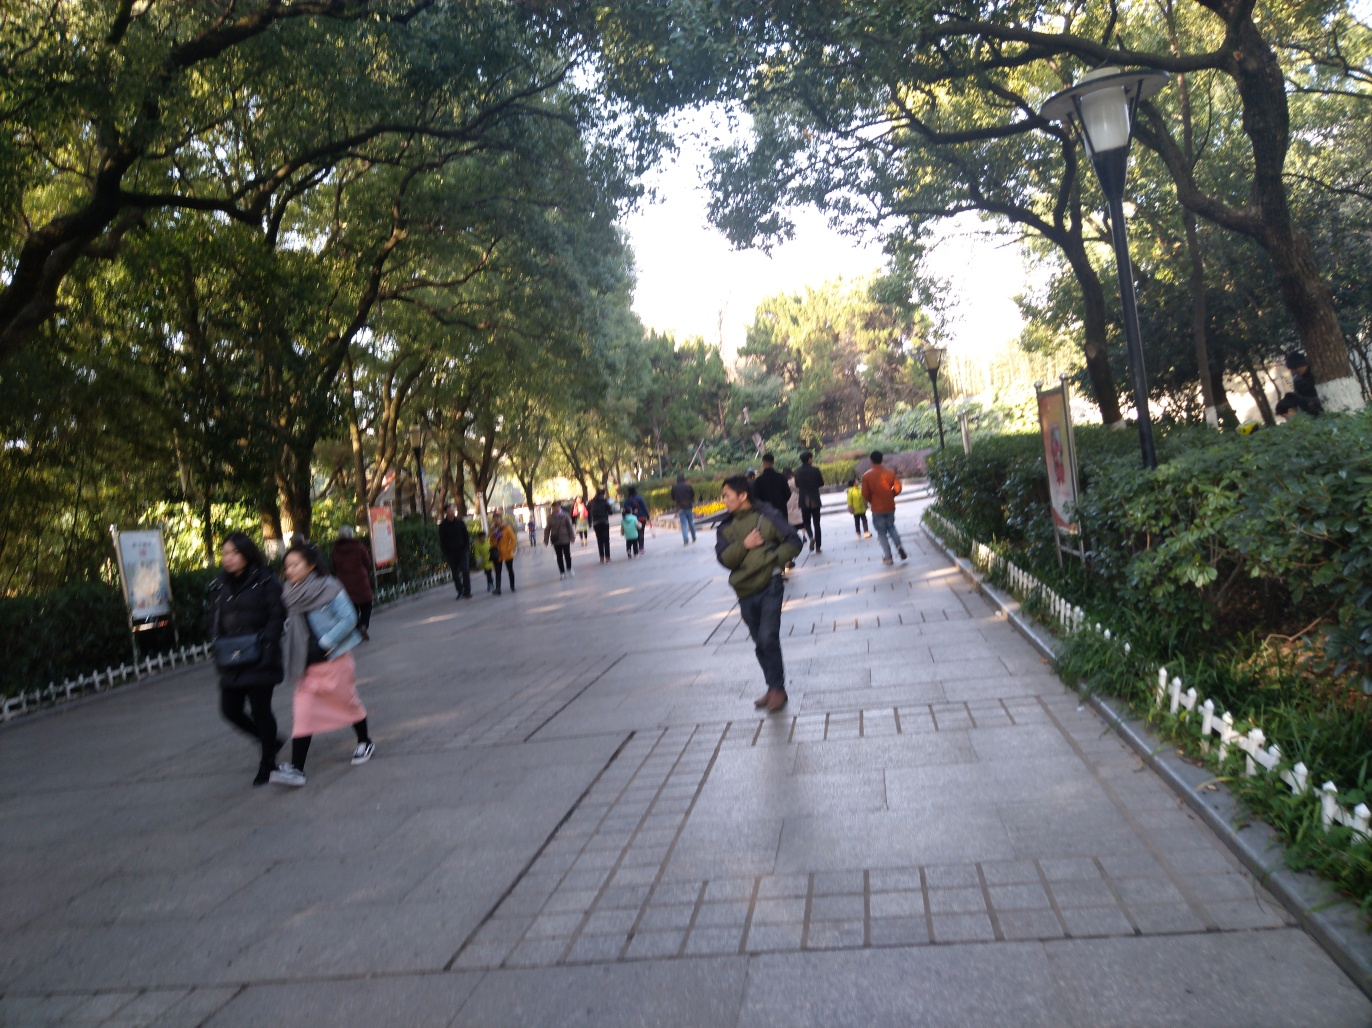Is the composition of this image good?
A. yes
B. perfect
C. excellent
D. no
Answer with the option's letter from the given choices directly. The composition of the image has some flaws. The photo appears to be taken with a slight tilt, affecting the balance and symmetry expected in a visually pleasing shot. Additionally, the image seems to be in motion blur which suggests that the camera wasn't steady during the shot. The subjects are also not in clear focus, and the lighting seems uncontrolled. While the scenery has potential, these technical issues suggest that the composition of the photo could be improved significantly. Therefore, a more accurate answer would be D. No, the composition could use improvement. 